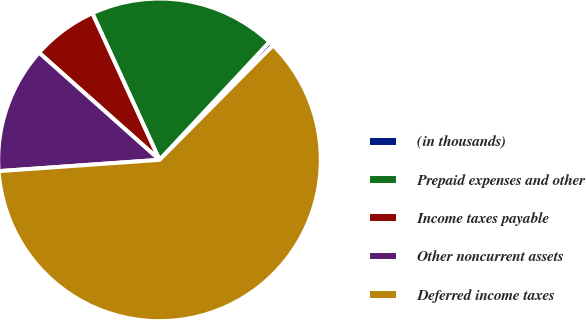Convert chart. <chart><loc_0><loc_0><loc_500><loc_500><pie_chart><fcel>(in thousands)<fcel>Prepaid expenses and other<fcel>Income taxes payable<fcel>Other noncurrent assets<fcel>Deferred income taxes<nl><fcel>0.49%<fcel>18.78%<fcel>6.59%<fcel>12.69%<fcel>61.45%<nl></chart> 